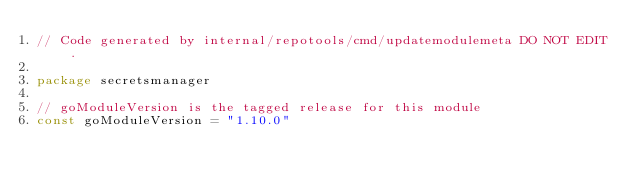Convert code to text. <code><loc_0><loc_0><loc_500><loc_500><_Go_>// Code generated by internal/repotools/cmd/updatemodulemeta DO NOT EDIT.

package secretsmanager

// goModuleVersion is the tagged release for this module
const goModuleVersion = "1.10.0"
</code> 